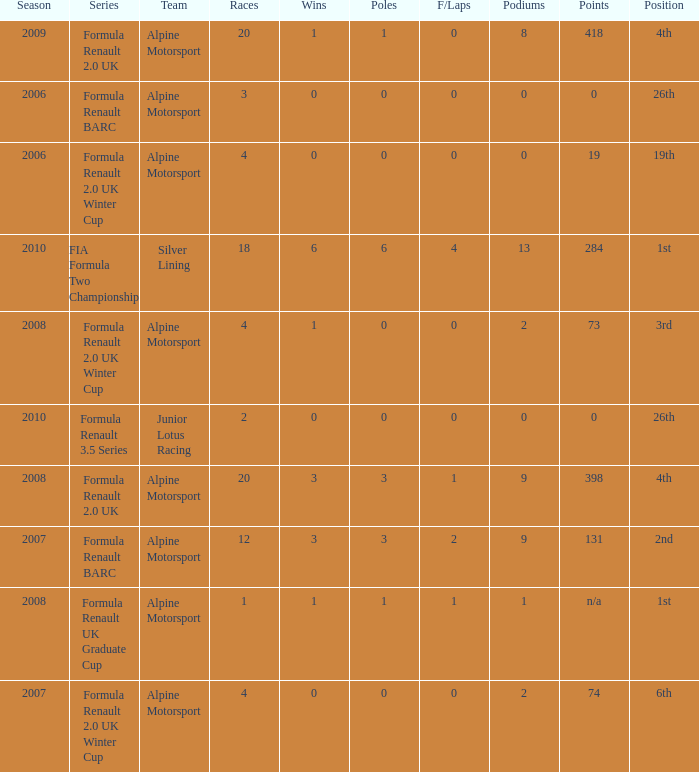How much were the f/laps if poles is higher than 1.0 during 2008? 1.0. 